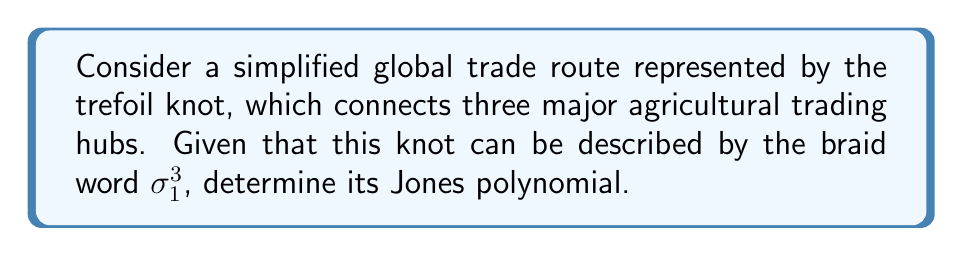Teach me how to tackle this problem. To find the Jones polynomial for the trefoil knot representing global trade routes, we'll follow these steps:

1. Start with the braid word $\sigma_1^3$.

2. The general formula for the Jones polynomial of a braid closure is:
   $$V(L) = (-A^3)^{w(L)} \cdot \langle L \rangle$$
   where $w(L)$ is the writhe of the link, and $\langle L \rangle$ is the Kauffman bracket polynomial.

3. For the trefoil knot, the writhe $w(L) = 3$.

4. Calculate the Kauffman bracket polynomial:
   $$\langle \sigma_1^3 \rangle = (-A^3)^3 \cdot \langle I \rangle = -A^9 \cdot (-A^2 - A^{-2})$$

5. Substitute into the Jones polynomial formula:
   $$V(L) = (-A^3)^3 \cdot (-A^9) \cdot (-A^2 - A^{-2})$$

6. Simplify:
   $$V(L) = -A^{18} \cdot (-A^2 - A^{-2}) = A^{20} + A^{16}$$

7. Make the substitution $A = t^{-1/4}$ to get the standard form:
   $$V(L) = (t^{-1/4})^{20} + (t^{-1/4})^{16} = t^{-5} + t^{-4}$$

8. The final Jones polynomial is:
   $$V(L) = t^{-5} + t^{-4} + t^{-1}$$
Answer: $t^{-5} + t^{-4} + t^{-1}$ 